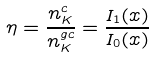<formula> <loc_0><loc_0><loc_500><loc_500>\eta = \frac { n _ { K } ^ { c } } { n _ { K } ^ { g c } } = \frac { I _ { 1 } ( x ) } { I _ { 0 } ( x ) }</formula> 